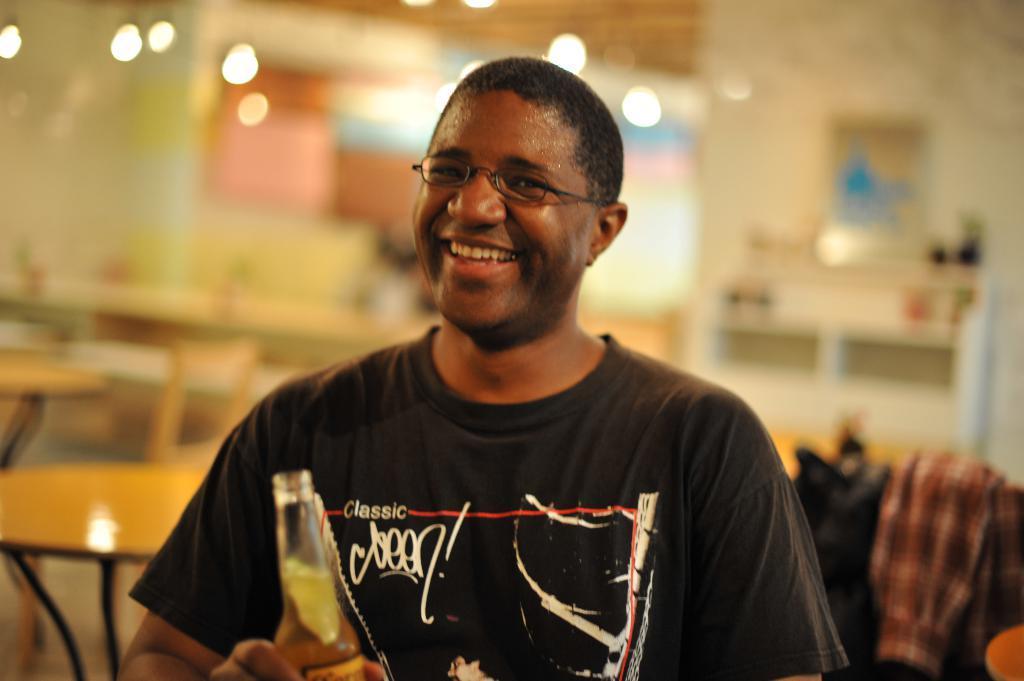In one or two sentences, can you explain what this image depicts? In this image I can see a man is holding an object in his hand and smiling 